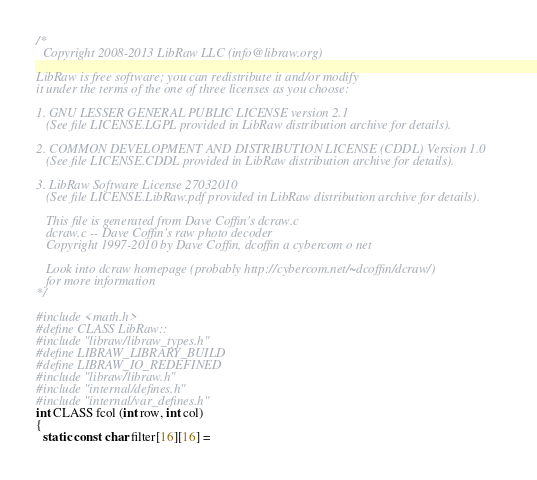Convert code to text. <code><loc_0><loc_0><loc_500><loc_500><_C++_>/* 
  Copyright 2008-2013 LibRaw LLC (info@libraw.org)

LibRaw is free software; you can redistribute it and/or modify
it under the terms of the one of three licenses as you choose:

1. GNU LESSER GENERAL PUBLIC LICENSE version 2.1
   (See file LICENSE.LGPL provided in LibRaw distribution archive for details).

2. COMMON DEVELOPMENT AND DISTRIBUTION LICENSE (CDDL) Version 1.0
   (See file LICENSE.CDDL provided in LibRaw distribution archive for details).

3. LibRaw Software License 27032010
   (See file LICENSE.LibRaw.pdf provided in LibRaw distribution archive for details).

   This file is generated from Dave Coffin's dcraw.c
   dcraw.c -- Dave Coffin's raw photo decoder
   Copyright 1997-2010 by Dave Coffin, dcoffin a cybercom o net

   Look into dcraw homepage (probably http://cybercom.net/~dcoffin/dcraw/)
   for more information
*/

#include <math.h>
#define CLASS LibRaw::
#include "libraw/libraw_types.h"
#define LIBRAW_LIBRARY_BUILD
#define LIBRAW_IO_REDEFINED
#include "libraw/libraw.h"
#include "internal/defines.h"
#include "internal/var_defines.h"
int CLASS fcol (int row, int col)
{
  static const char filter[16][16] =</code> 